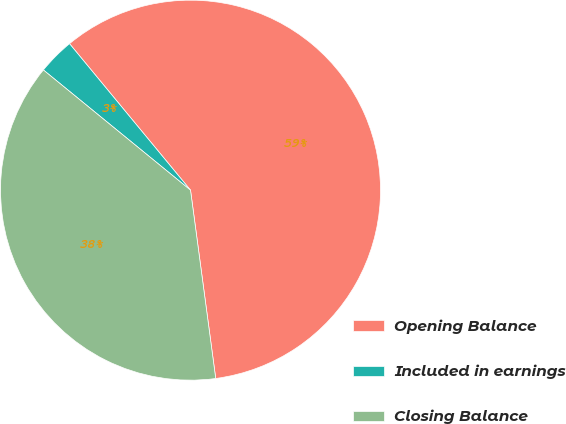Convert chart. <chart><loc_0><loc_0><loc_500><loc_500><pie_chart><fcel>Opening Balance<fcel>Included in earnings<fcel>Closing Balance<nl><fcel>58.87%<fcel>3.11%<fcel>38.02%<nl></chart> 